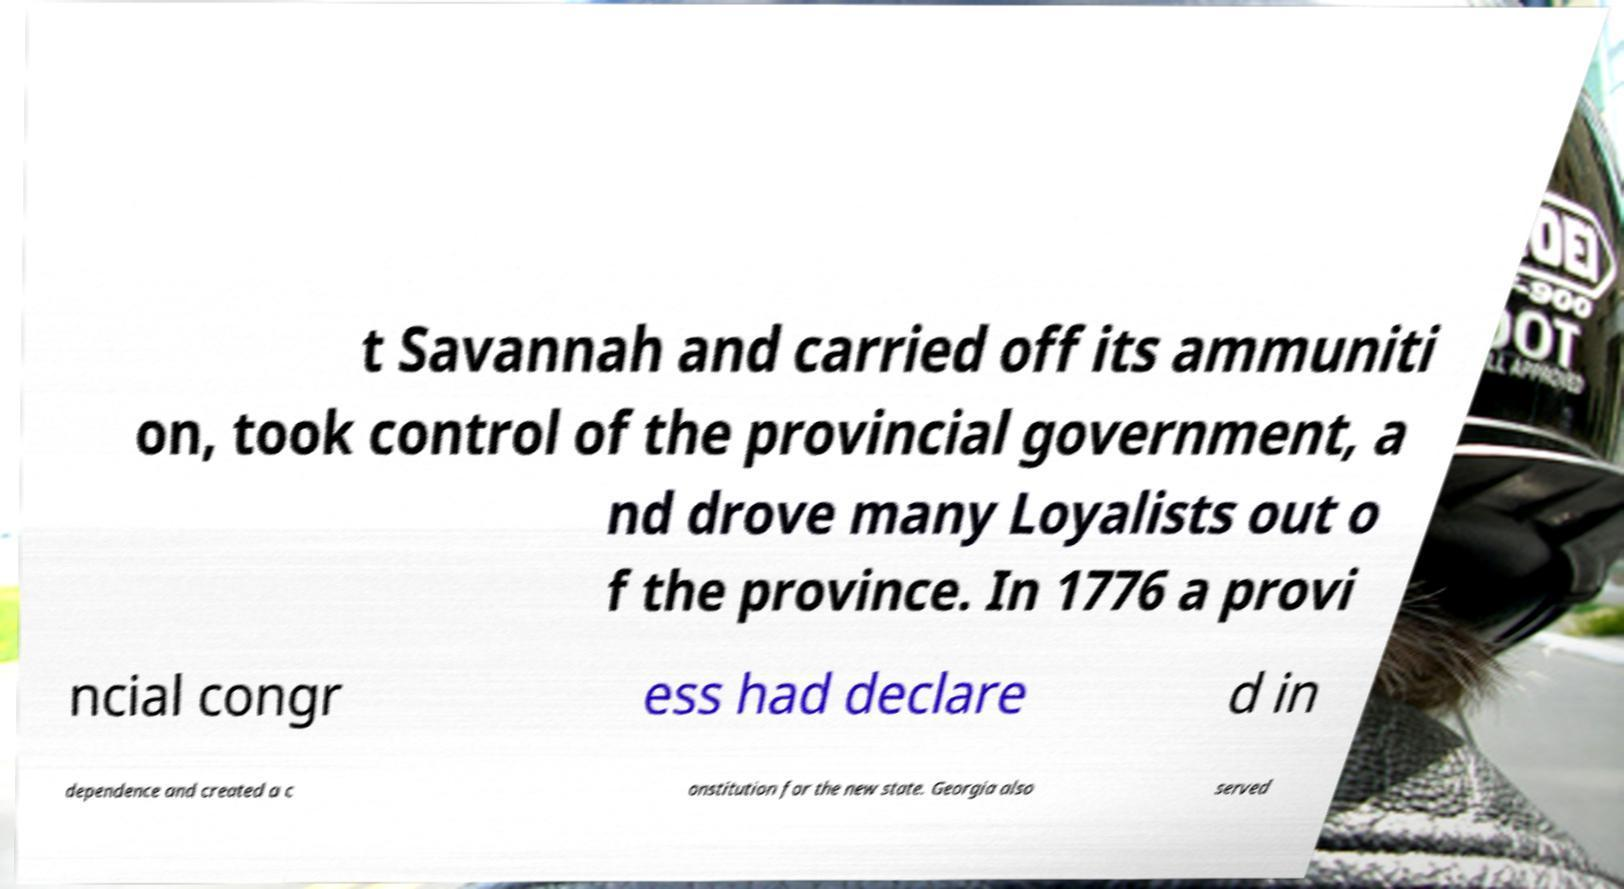Please identify and transcribe the text found in this image. t Savannah and carried off its ammuniti on, took control of the provincial government, a nd drove many Loyalists out o f the province. In 1776 a provi ncial congr ess had declare d in dependence and created a c onstitution for the new state. Georgia also served 